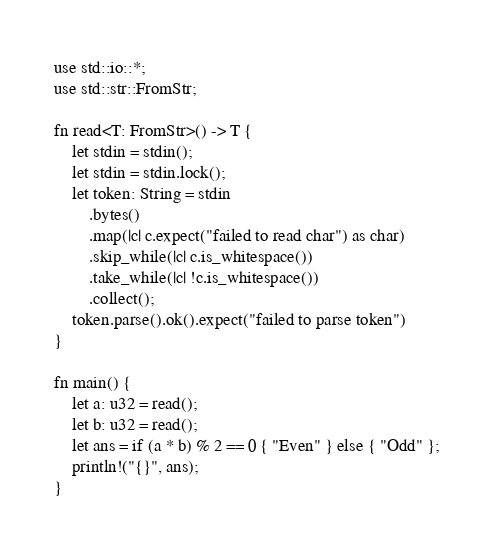<code> <loc_0><loc_0><loc_500><loc_500><_Rust_>use std::io::*;
use std::str::FromStr;

fn read<T: FromStr>() -> T {
    let stdin = stdin();
    let stdin = stdin.lock();
    let token: String = stdin
        .bytes()
        .map(|c| c.expect("failed to read char") as char) 
        .skip_while(|c| c.is_whitespace())
        .take_while(|c| !c.is_whitespace())
        .collect();
    token.parse().ok().expect("failed to parse token")
}

fn main() {
    let a: u32 = read();
    let b: u32 = read();
    let ans = if (a * b) % 2 == 0 { "Even" } else { "Odd" };
    println!("{}", ans);
}
</code> 